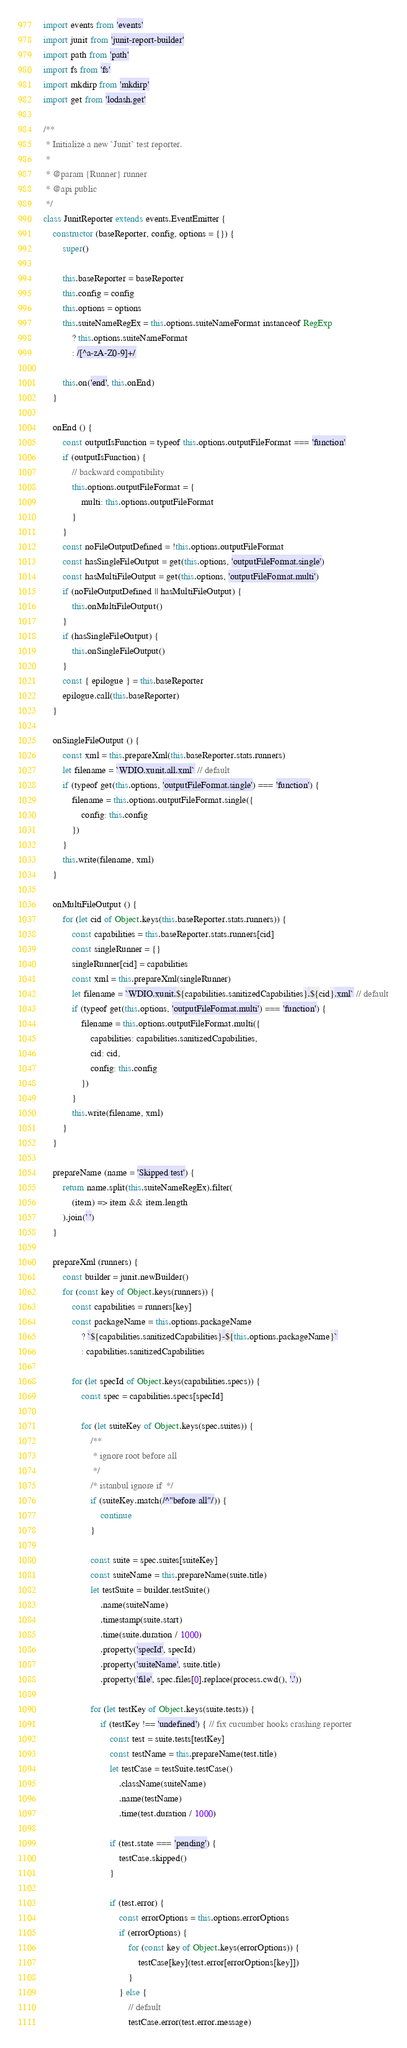<code> <loc_0><loc_0><loc_500><loc_500><_JavaScript_>import events from 'events'
import junit from 'junit-report-builder'
import path from 'path'
import fs from 'fs'
import mkdirp from 'mkdirp'
import get from 'lodash.get'

/**
 * Initialize a new `Junit` test reporter.
 *
 * @param {Runner} runner
 * @api public
 */
class JunitReporter extends events.EventEmitter {
    constructor (baseReporter, config, options = {}) {
        super()

        this.baseReporter = baseReporter
        this.config = config
        this.options = options
        this.suiteNameRegEx = this.options.suiteNameFormat instanceof RegExp
            ? this.options.suiteNameFormat
            : /[^a-zA-Z0-9]+/

        this.on('end', this.onEnd)
    }

    onEnd () {
        const outputIsFunction = typeof this.options.outputFileFormat === 'function'
        if (outputIsFunction) {
            // backward compatibility
            this.options.outputFileFormat = {
                multi: this.options.outputFileFormat
            }
        }
        const noFileOutputDefined = !this.options.outputFileFormat
        const hasSingleFileOutput = get(this.options, 'outputFileFormat.single')
        const hasMultiFileOutput = get(this.options, 'outputFileFormat.multi')
        if (noFileOutputDefined || hasMultiFileOutput) {
            this.onMultiFileOutput()
        }
        if (hasSingleFileOutput) {
            this.onSingleFileOutput()
        }
        const { epilogue } = this.baseReporter
        epilogue.call(this.baseReporter)
    }

    onSingleFileOutput () {
        const xml = this.prepareXml(this.baseReporter.stats.runners)
        let filename = `WDIO.xunit.all.xml` // default
        if (typeof get(this.options, 'outputFileFormat.single') === 'function') {
            filename = this.options.outputFileFormat.single({
                config: this.config
            })
        }
        this.write(filename, xml)
    }

    onMultiFileOutput () {
        for (let cid of Object.keys(this.baseReporter.stats.runners)) {
            const capabilities = this.baseReporter.stats.runners[cid]
            const singleRunner = {}
            singleRunner[cid] = capabilities
            const xml = this.prepareXml(singleRunner)
            let filename = `WDIO.xunit.${capabilities.sanitizedCapabilities}.${cid}.xml` // default
            if (typeof get(this.options, 'outputFileFormat.multi') === 'function') {
                filename = this.options.outputFileFormat.multi({
                    capabilities: capabilities.sanitizedCapabilities,
                    cid: cid,
                    config: this.config
                })
            }
            this.write(filename, xml)
        }
    }

    prepareName (name = 'Skipped test') {
        return name.split(this.suiteNameRegEx).filter(
            (item) => item && item.length
        ).join(' ')
    }

    prepareXml (runners) {
        const builder = junit.newBuilder()
        for (const key of Object.keys(runners)) {
            const capabilities = runners[key]
            const packageName = this.options.packageName
                ? `${capabilities.sanitizedCapabilities}-${this.options.packageName}`
                : capabilities.sanitizedCapabilities

            for (let specId of Object.keys(capabilities.specs)) {
                const spec = capabilities.specs[specId]

                for (let suiteKey of Object.keys(spec.suites)) {
                    /**
                     * ignore root before all
                     */
                    /* istanbul ignore if  */
                    if (suiteKey.match(/^"before all"/)) {
                        continue
                    }

                    const suite = spec.suites[suiteKey]
                    const suiteName = this.prepareName(suite.title)
                    let testSuite = builder.testSuite()
                        .name(suiteName)
                        .timestamp(suite.start)
                        .time(suite.duration / 1000)
                        .property('specId', specId)
                        .property('suiteName', suite.title)
                        .property('file', spec.files[0].replace(process.cwd(), '.'))

                    for (let testKey of Object.keys(suite.tests)) {
                        if (testKey !== 'undefined') { // fix cucumber hooks crashing reporter
                            const test = suite.tests[testKey]
                            const testName = this.prepareName(test.title)
                            let testCase = testSuite.testCase()
                                .className(suiteName)
                                .name(testName)
                                .time(test.duration / 1000)

                            if (test.state === 'pending') {
                                testCase.skipped()
                            }

                            if (test.error) {
                                const errorOptions = this.options.errorOptions
                                if (errorOptions) {
                                    for (const key of Object.keys(errorOptions)) {
                                        testCase[key](test.error[errorOptions[key]])
                                    }
                                } else {
                                    // default
                                    testCase.error(test.error.message)</code> 